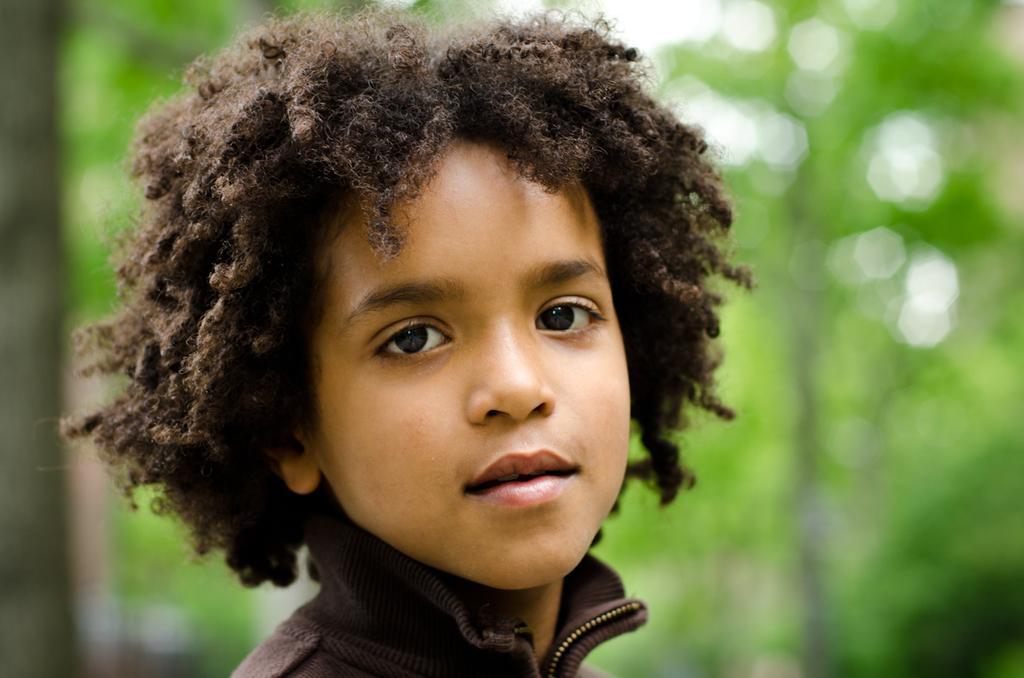What is the main subject of the image? The main subject of the image is a boy. What is the boy doing in the image? The boy is looking at his side. What is the boy wearing in the image? The boy is wearing a brown color coat. What type of jar can be seen in the image? There is no jar present in the image. What scientific experiment is the boy conducting in the image? There is no scientific experiment visible in the image. What type of weather condition is present in the image? The provided facts do not mention any weather conditions, so it cannot be determined from the image. 